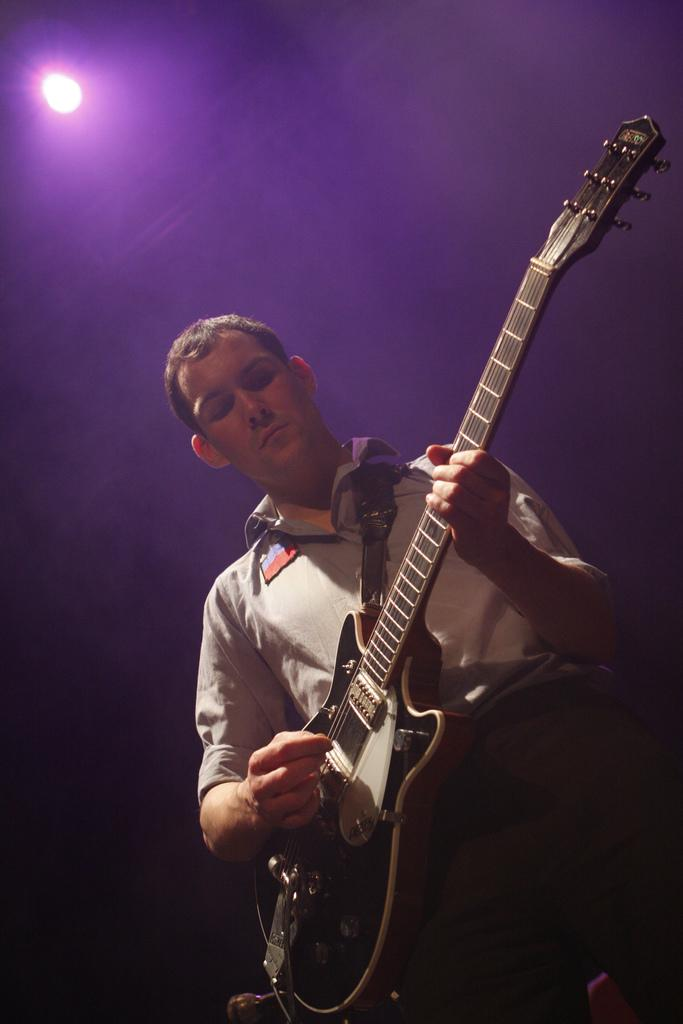What is the main subject of the image? There is a man in the image. What is the man doing in the image? The man is standing and playing the guitar. What object is the man holding in the image? The man is holding a guitar. Can you describe the lighting in the image? There is a light visible at the top left of the image. What type of orange can be seen in the image? There is no orange present in the image. What prose is the man reciting while playing the guitar in the image? The image does not show the man reciting any prose; he is only playing the guitar. 